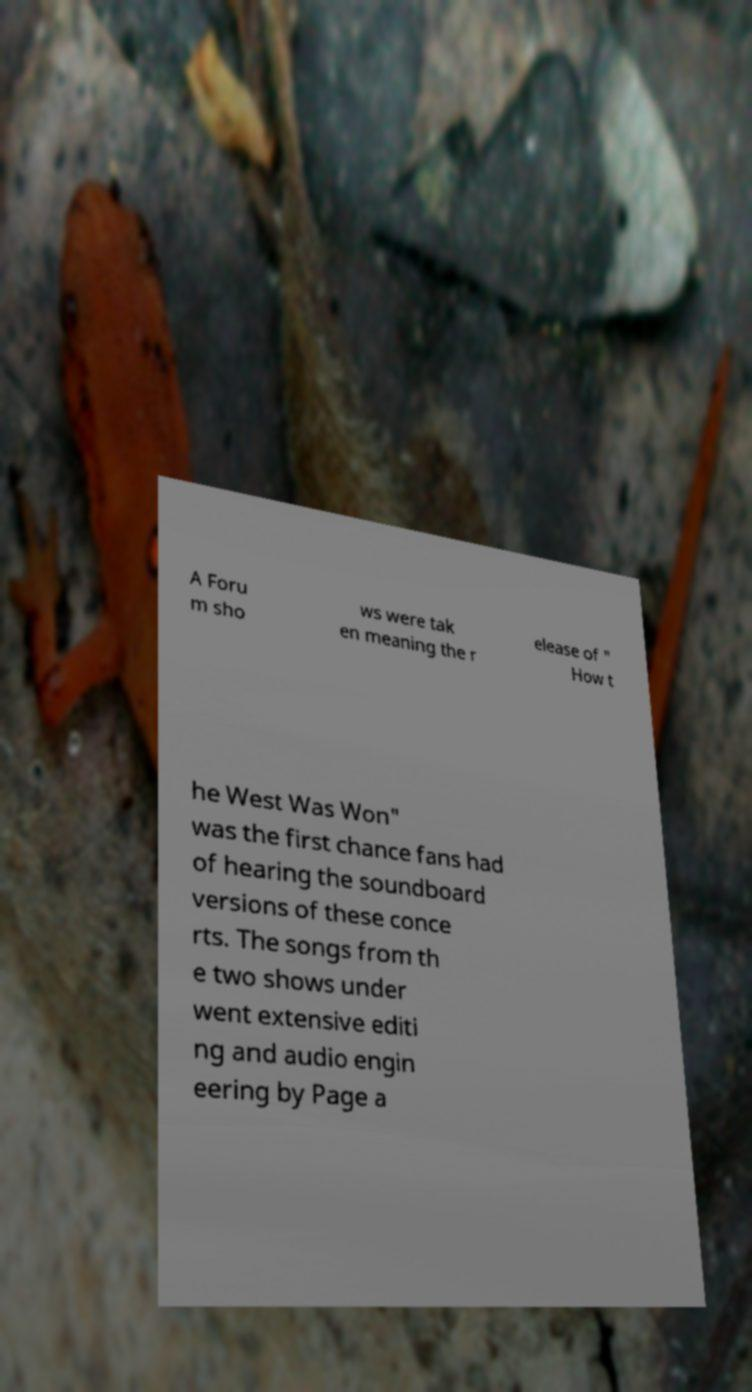Please read and relay the text visible in this image. What does it say? A Foru m sho ws were tak en meaning the r elease of " How t he West Was Won" was the first chance fans had of hearing the soundboard versions of these conce rts. The songs from th e two shows under went extensive editi ng and audio engin eering by Page a 